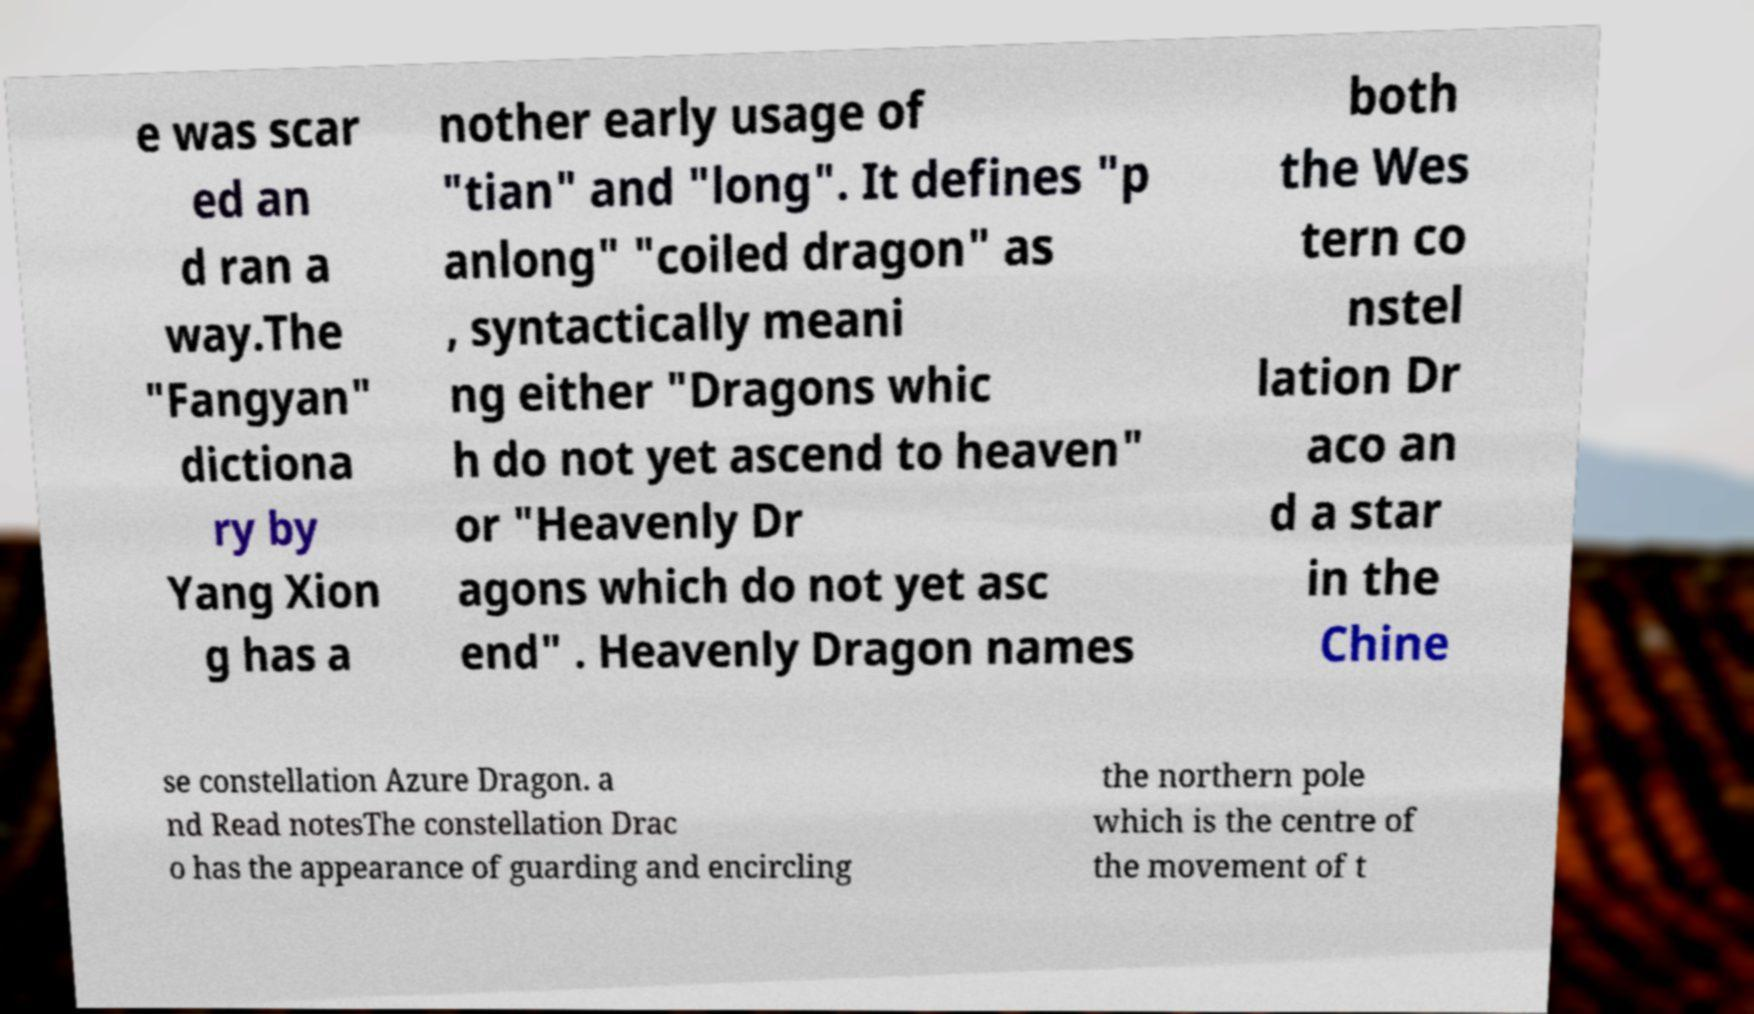Can you accurately transcribe the text from the provided image for me? e was scar ed an d ran a way.The "Fangyan" dictiona ry by Yang Xion g has a nother early usage of "tian" and "long". It defines "p anlong" "coiled dragon" as , syntactically meani ng either "Dragons whic h do not yet ascend to heaven" or "Heavenly Dr agons which do not yet asc end" . Heavenly Dragon names both the Wes tern co nstel lation Dr aco an d a star in the Chine se constellation Azure Dragon. a nd Read notesThe constellation Drac o has the appearance of guarding and encircling the northern pole which is the centre of the movement of t 